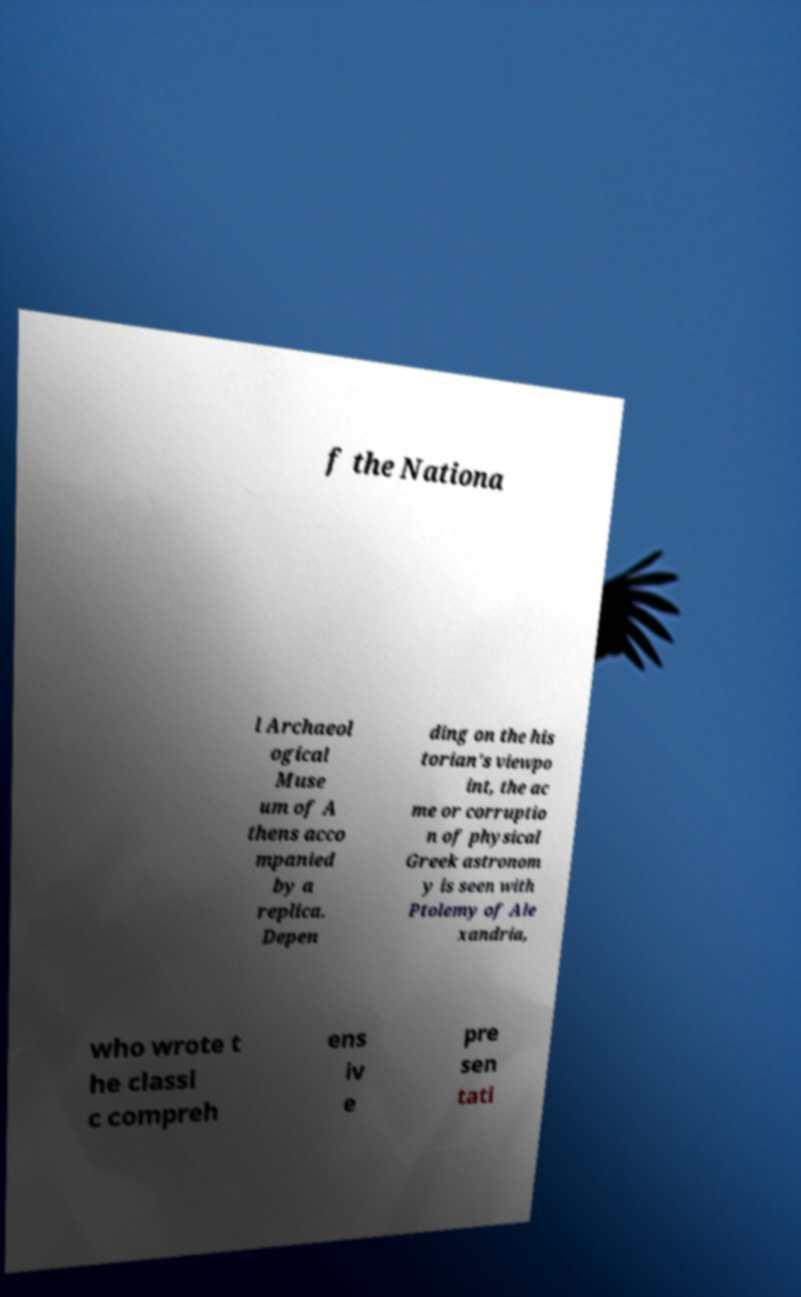Could you extract and type out the text from this image? f the Nationa l Archaeol ogical Muse um of A thens acco mpanied by a replica. Depen ding on the his torian's viewpo int, the ac me or corruptio n of physical Greek astronom y is seen with Ptolemy of Ale xandria, who wrote t he classi c compreh ens iv e pre sen tati 